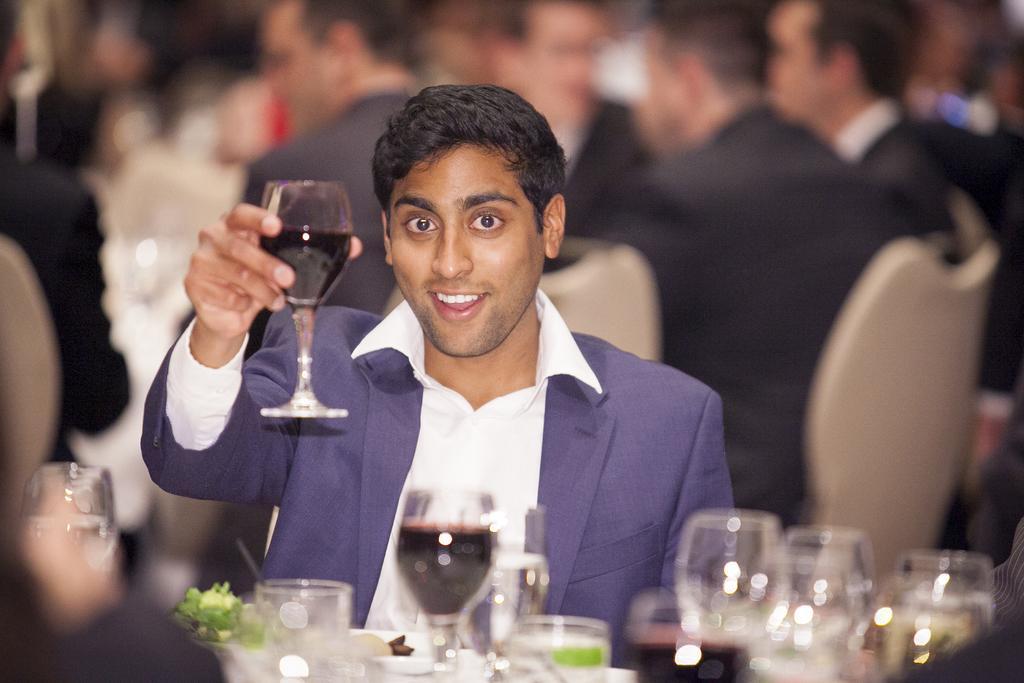Can you describe this image briefly? In the front of the image I can see a man is holding a glass. In-front of that man there are glasses, food and objects. In the background of the image is blurred. There are people and chairs. 